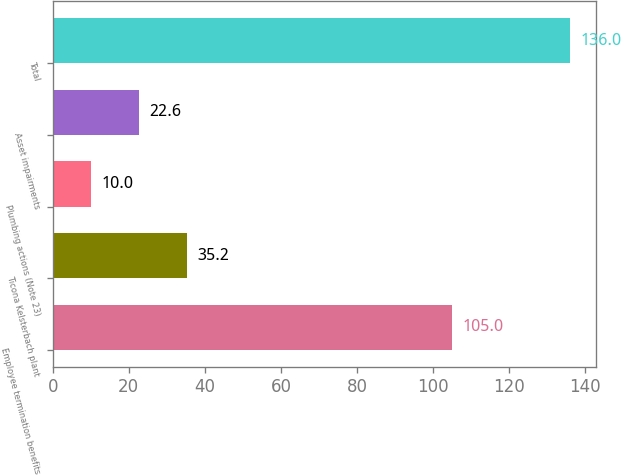<chart> <loc_0><loc_0><loc_500><loc_500><bar_chart><fcel>Employee termination benefits<fcel>Ticona Kelsterbach plant<fcel>Plumbing actions (Note 23)<fcel>Asset impairments<fcel>Total<nl><fcel>105<fcel>35.2<fcel>10<fcel>22.6<fcel>136<nl></chart> 